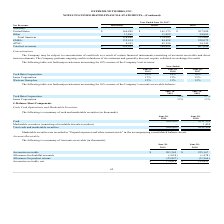From Extreme Networks's financial document, Which years does the table provide information for the company's Accounts receivable? The document shows two values: 2019 and 2018. From the document: "2019 2018..." Also, What was the amount of accounts receivable in 2018? According to the financial document, 225,167 (in thousands). The relevant text states: "Accounts receivable $ 201,365 $ 225,167..." Also, What was the allowance for product returns in 2019? According to the financial document, (25,897) (in thousands). The relevant text states: "Allowance for product returns (25,897) (11,266)..." Also, How many years did the net accounts receivable exceed $200,000 thousand? Based on the analysis, there are 1 instances. The counting process: 2018. Also, can you calculate: What was the change in the Allowance for doubtful accounts between 2018 and 2019? Based on the calculation: -1,054-(-1,478), the result is 424 (in thousands). This is based on the information: "Allowance for doubtful accounts (1,054) (1,478) Allowance for doubtful accounts (1,054) (1,478)..." The key data points involved are: 1,054, 1,478. Also, can you calculate: What was the percentage change in the Allowance for product returns between 2018 and 2019? To answer this question, I need to perform calculations using the financial data. The calculation is: (-25,897+11,266)/-11,266, which equals 129.87 (percentage). This is based on the information: "Allowance for product returns (25,897) (11,266) Allowance for product returns (25,897) (11,266)..." The key data points involved are: 11,266, 25,897. 